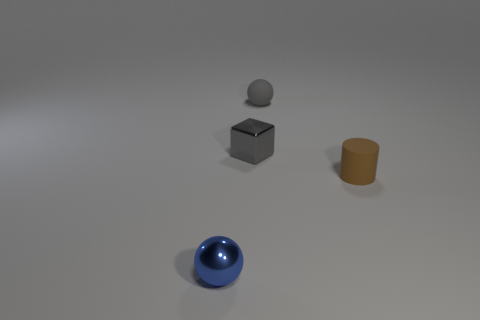How many shiny things are either green things or brown things?
Your response must be concise. 0. There is a brown thing that is the same size as the gray shiny thing; what is its material?
Offer a very short reply. Rubber. Is there a tiny ball that has the same material as the small blue thing?
Give a very brief answer. No. What is the shape of the tiny matte thing to the right of the tiny matte thing behind the small brown matte thing that is in front of the rubber sphere?
Offer a very short reply. Cylinder. Do the gray block and the gray rubber ball on the right side of the small block have the same size?
Provide a short and direct response. Yes. What is the shape of the thing that is both to the left of the brown thing and in front of the small gray shiny cube?
Offer a terse response. Sphere. How many large things are either cylinders or green metal things?
Offer a very short reply. 0. Are there an equal number of small gray balls behind the blue thing and small blue spheres that are behind the brown cylinder?
Keep it short and to the point. No. What number of other things are there of the same color as the metallic block?
Your response must be concise. 1. Are there an equal number of rubber balls to the right of the tiny matte cylinder and small blue objects?
Give a very brief answer. No. 